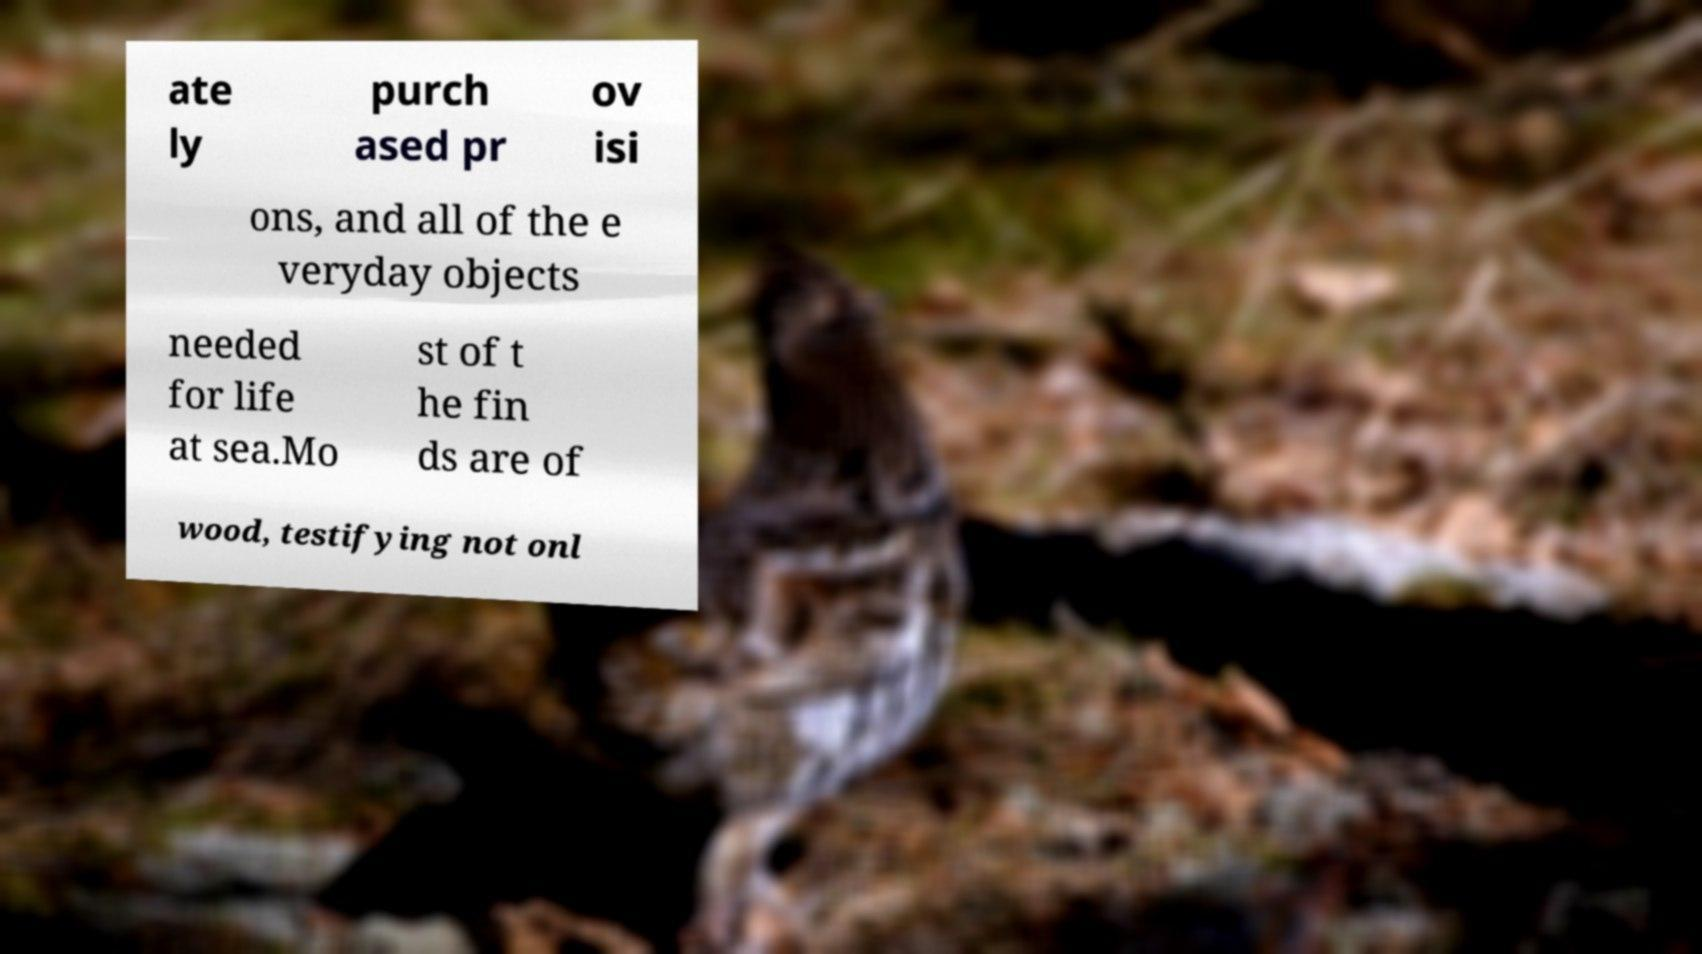Please read and relay the text visible in this image. What does it say? ate ly purch ased pr ov isi ons, and all of the e veryday objects needed for life at sea.Mo st of t he fin ds are of wood, testifying not onl 